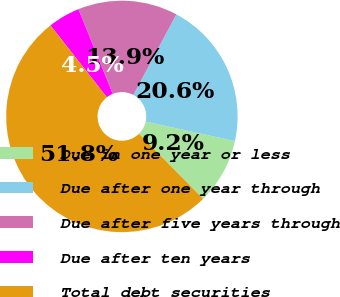<chart> <loc_0><loc_0><loc_500><loc_500><pie_chart><fcel>Due in one year or less<fcel>Due after one year through<fcel>Due after five years through<fcel>Due after ten years<fcel>Total debt securities<nl><fcel>9.2%<fcel>20.62%<fcel>13.93%<fcel>4.47%<fcel>51.79%<nl></chart> 